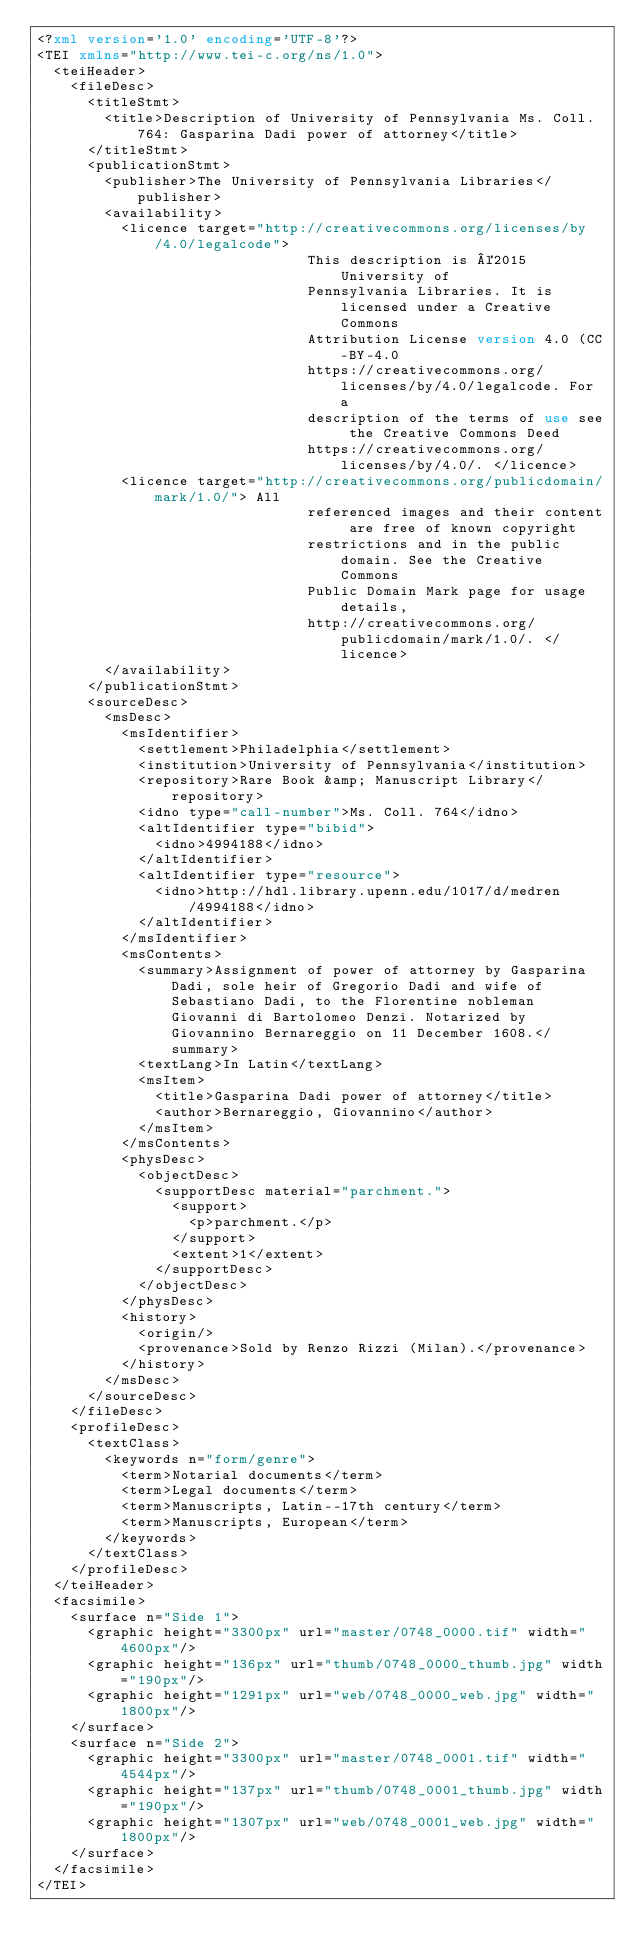<code> <loc_0><loc_0><loc_500><loc_500><_XML_><?xml version='1.0' encoding='UTF-8'?>
<TEI xmlns="http://www.tei-c.org/ns/1.0">
  <teiHeader>
    <fileDesc>
      <titleStmt>
        <title>Description of University of Pennsylvania Ms. Coll. 764: Gasparina Dadi power of attorney</title>
      </titleStmt>
      <publicationStmt>
        <publisher>The University of Pennsylvania Libraries</publisher>
        <availability>
          <licence target="http://creativecommons.org/licenses/by/4.0/legalcode">
                                This description is ©2015 University of
                                Pennsylvania Libraries. It is licensed under a Creative Commons
                                Attribution License version 4.0 (CC-BY-4.0
                                https://creativecommons.org/licenses/by/4.0/legalcode. For a
                                description of the terms of use see the Creative Commons Deed
                                https://creativecommons.org/licenses/by/4.0/. </licence>
          <licence target="http://creativecommons.org/publicdomain/mark/1.0/"> All
                                referenced images and their content are free of known copyright
                                restrictions and in the public domain. See the Creative Commons
                                Public Domain Mark page for usage details,
                                http://creativecommons.org/publicdomain/mark/1.0/. </licence>
        </availability>
      </publicationStmt>
      <sourceDesc>
        <msDesc>
          <msIdentifier>
            <settlement>Philadelphia</settlement>
            <institution>University of Pennsylvania</institution>
            <repository>Rare Book &amp; Manuscript Library</repository>
            <idno type="call-number">Ms. Coll. 764</idno>
            <altIdentifier type="bibid">
              <idno>4994188</idno>
            </altIdentifier>
            <altIdentifier type="resource">
              <idno>http://hdl.library.upenn.edu/1017/d/medren/4994188</idno>
            </altIdentifier>
          </msIdentifier>
          <msContents>
            <summary>Assignment of power of attorney by Gasparina Dadi, sole heir of Gregorio Dadi and wife of Sebastiano Dadi, to the Florentine nobleman Giovanni di Bartolomeo Denzi. Notarized by Giovannino Bernareggio on 11 December 1608.</summary>
            <textLang>In Latin</textLang>
            <msItem>
              <title>Gasparina Dadi power of attorney</title>
              <author>Bernareggio, Giovannino</author>
            </msItem>
          </msContents>
          <physDesc>
            <objectDesc>
              <supportDesc material="parchment.">
                <support>
                  <p>parchment.</p>
                </support>
                <extent>1</extent>
              </supportDesc>
            </objectDesc>
          </physDesc>
          <history>
            <origin/>
            <provenance>Sold by Renzo Rizzi (Milan).</provenance>
          </history>
        </msDesc>
      </sourceDesc>
    </fileDesc>
    <profileDesc>
      <textClass>
        <keywords n="form/genre">
          <term>Notarial documents</term>
          <term>Legal documents</term>
          <term>Manuscripts, Latin--17th century</term>
          <term>Manuscripts, European</term>
        </keywords>
      </textClass>
    </profileDesc>
  </teiHeader>
  <facsimile>
    <surface n="Side 1">
      <graphic height="3300px" url="master/0748_0000.tif" width="4600px"/>
      <graphic height="136px" url="thumb/0748_0000_thumb.jpg" width="190px"/>
      <graphic height="1291px" url="web/0748_0000_web.jpg" width="1800px"/>
    </surface>
    <surface n="Side 2">
      <graphic height="3300px" url="master/0748_0001.tif" width="4544px"/>
      <graphic height="137px" url="thumb/0748_0001_thumb.jpg" width="190px"/>
      <graphic height="1307px" url="web/0748_0001_web.jpg" width="1800px"/>
    </surface>
  </facsimile>
</TEI>
</code> 